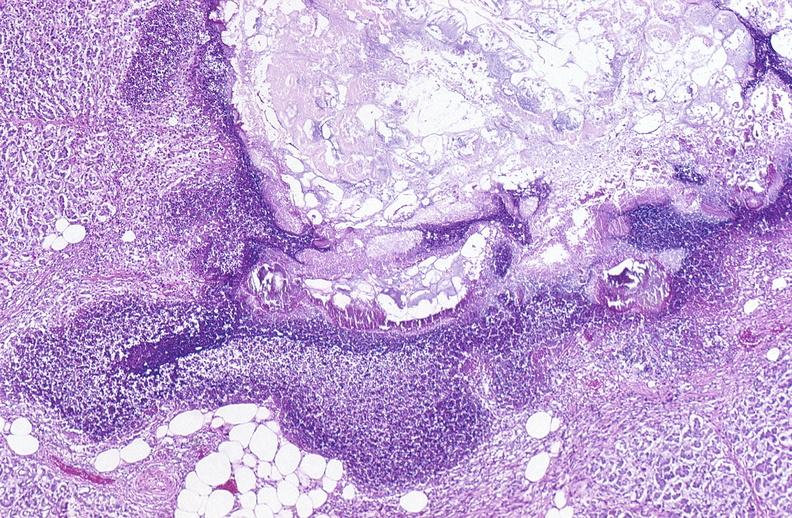where is this?
Answer the question using a single word or phrase. Pancreas 